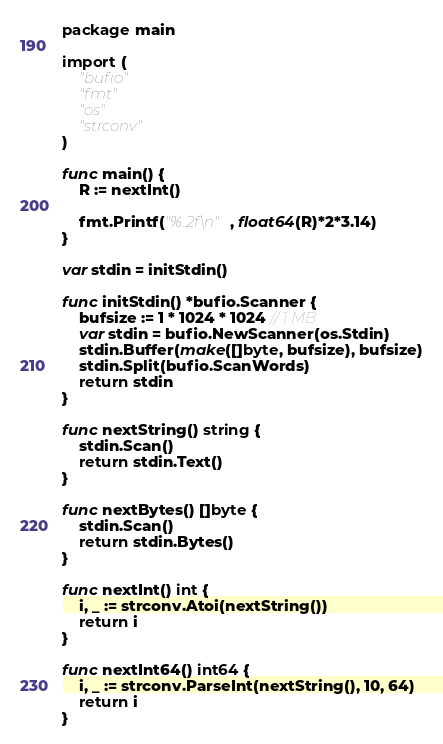<code> <loc_0><loc_0><loc_500><loc_500><_Go_>package main

import (
	"bufio"
	"fmt"
	"os"
	"strconv"
)

func main() {
	R := nextInt()

	fmt.Printf("%.2f\n", float64(R)*2*3.14)
}

var stdin = initStdin()

func initStdin() *bufio.Scanner {
	bufsize := 1 * 1024 * 1024 // 1 MB
	var stdin = bufio.NewScanner(os.Stdin)
	stdin.Buffer(make([]byte, bufsize), bufsize)
	stdin.Split(bufio.ScanWords)
	return stdin
}

func nextString() string {
	stdin.Scan()
	return stdin.Text()
}

func nextBytes() []byte {
	stdin.Scan()
	return stdin.Bytes()
}

func nextInt() int {
	i, _ := strconv.Atoi(nextString())
	return i
}

func nextInt64() int64 {
	i, _ := strconv.ParseInt(nextString(), 10, 64)
	return i
}
</code> 